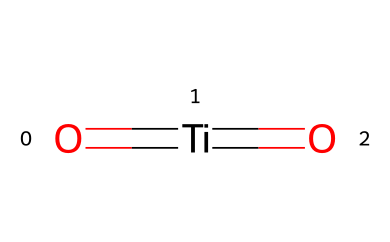What is the central atom in this compound? The chemical structure includes titanium indicated as the central atom surrounded by oxygens. The SMILES representation shows the titanium atom (Ti) as the main element.
Answer: titanium How many oxygen atoms are present? The SMILES indicates two double bonds to oxygen atoms (=O), which means there are two oxygen atoms bonded to titanium.
Answer: two What type of bonding is observed in this compound? The structure shows double bonds between titanium and each oxygen atom, indicating covalent bonding. This type of bonding occurs when atoms share electrons to achieve stability.
Answer: covalent Which property makes this chemical photoreactive? The presence of titanium in the structure, combined with the ability of the bonds to absorb UV light, makes it effective in photoreactive applications such as sunscreen.
Answer: titanium How many total atoms are in this molecule? The structure includes one titanium atom and two oxygen atoms, resulting in a total of three atoms. We count each atom in the formula to determine the total.
Answer: three Does this chemical have a specific application in the context of UV protection? Yes, titanium dioxide is widely used in sunscreens for its ability to absorb and scatter UV radiation, offering protection against harmful UV light, which is essential for communities exposed to high UV environments.
Answer: UV protection 